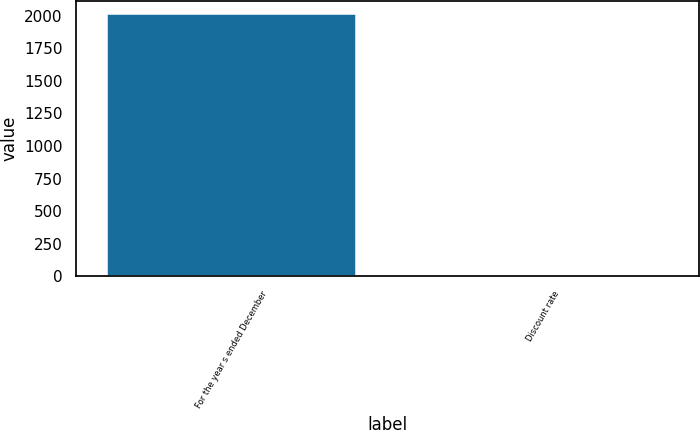<chart> <loc_0><loc_0><loc_500><loc_500><bar_chart><fcel>For the year s ended December<fcel>Discount rate<nl><fcel>2011<fcel>5.2<nl></chart> 